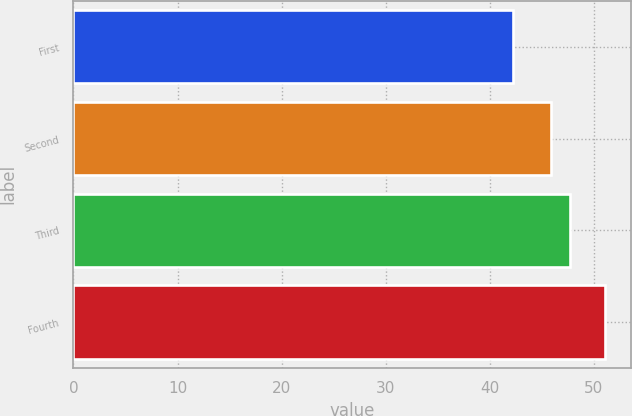<chart> <loc_0><loc_0><loc_500><loc_500><bar_chart><fcel>First<fcel>Second<fcel>Third<fcel>Fourth<nl><fcel>42.26<fcel>45.9<fcel>47.75<fcel>51.06<nl></chart> 